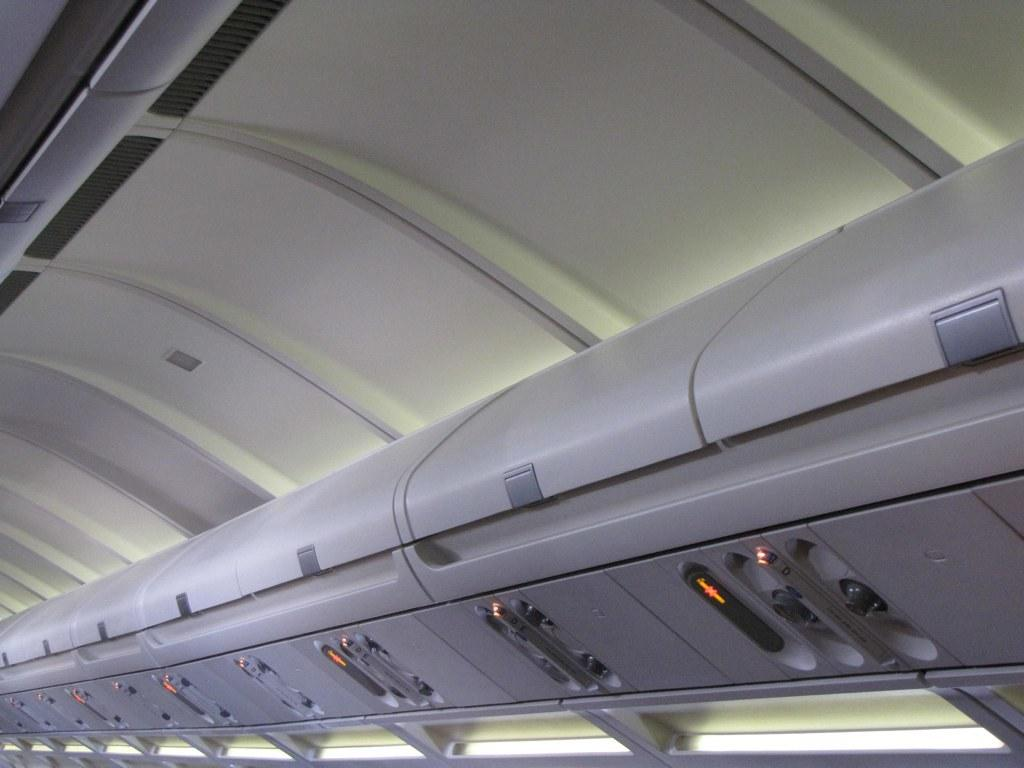What type of furniture is present in the image? There are luggage desks in the image. Where are the luggage desks located? The luggage desks are inside an airplane. What type of dinner is being served on the luggage desks in the image? There is no dinner or food visible on the luggage desks in the image. 